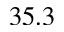Convert formula to latex. <formula><loc_0><loc_0><loc_500><loc_500>3 5 . 3</formula> 